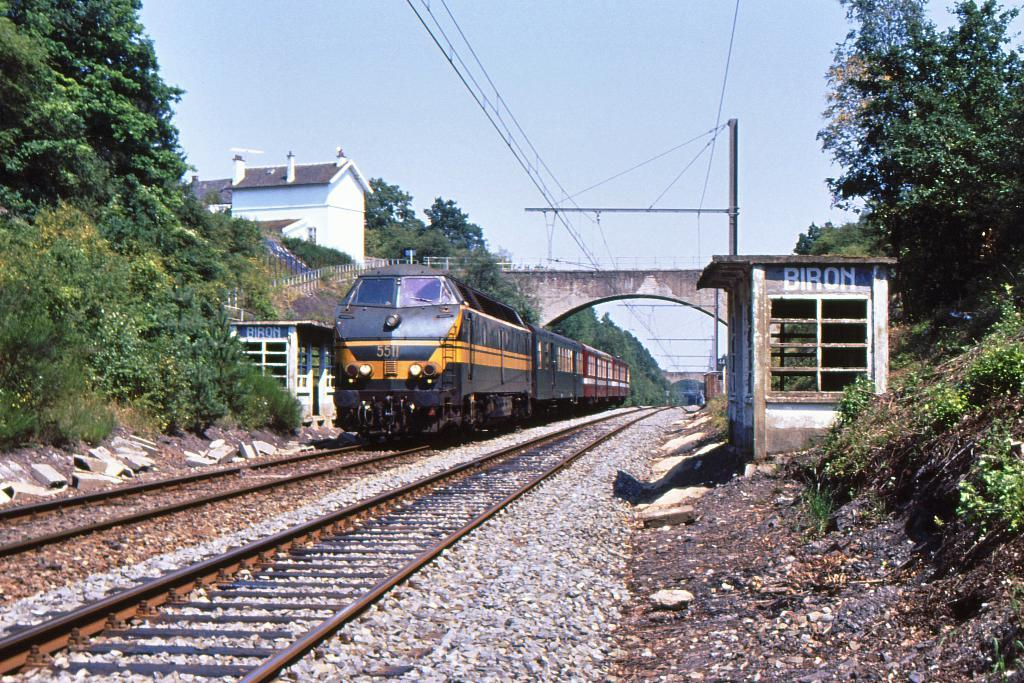What is the main mode of transportation in the image? There is a train on the track in the image. What type of structure can be seen in the image? There is a house with a roof in the image. What type of vegetation is present in the image? There are trees in the image. What is the purpose of the pole with wires in the image? The pole with wires is likely for electrical or communication purposes. What type of architectural feature is present in the image? There is a bridge in the image. What is visible in the background of the image? The sky is visible in the image. Can you describe the woman's knee in the image? There is no woman present in the image, so it is not possible to describe her knee. What type of glove is the person wearing in the image? There is no person wearing a glove in the image. 